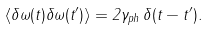<formula> <loc_0><loc_0><loc_500><loc_500>\langle \delta \omega ( t ) \delta \omega ( t ^ { \prime } ) \rangle = 2 \gamma _ { p h } \, \delta ( t - t ^ { \prime } ) .</formula> 